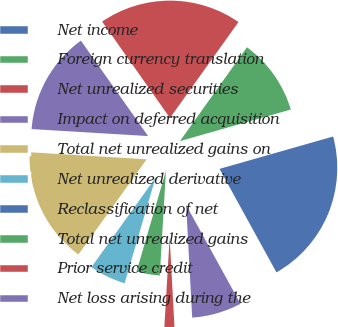Convert chart. <chart><loc_0><loc_0><loc_500><loc_500><pie_chart><fcel>Net income<fcel>Foreign currency translation<fcel>Net unrealized securities<fcel>Impact on deferred acquisition<fcel>Total net unrealized gains on<fcel>Net unrealized derivative<fcel>Reclassification of net<fcel>Total net unrealized gains<fcel>Prior service credit<fcel>Net loss arising during the<nl><fcel>21.41%<fcel>10.71%<fcel>19.63%<fcel>14.28%<fcel>16.06%<fcel>5.36%<fcel>0.01%<fcel>3.58%<fcel>1.8%<fcel>7.15%<nl></chart> 